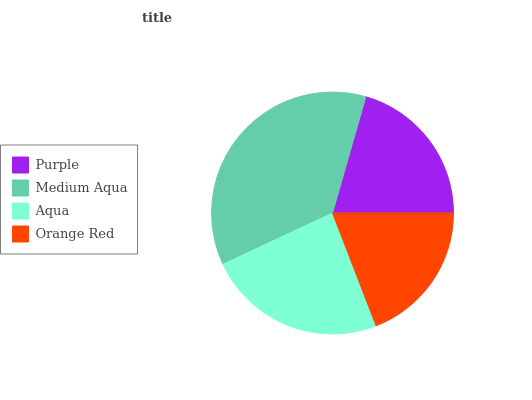Is Orange Red the minimum?
Answer yes or no. Yes. Is Medium Aqua the maximum?
Answer yes or no. Yes. Is Aqua the minimum?
Answer yes or no. No. Is Aqua the maximum?
Answer yes or no. No. Is Medium Aqua greater than Aqua?
Answer yes or no. Yes. Is Aqua less than Medium Aqua?
Answer yes or no. Yes. Is Aqua greater than Medium Aqua?
Answer yes or no. No. Is Medium Aqua less than Aqua?
Answer yes or no. No. Is Aqua the high median?
Answer yes or no. Yes. Is Purple the low median?
Answer yes or no. Yes. Is Orange Red the high median?
Answer yes or no. No. Is Orange Red the low median?
Answer yes or no. No. 